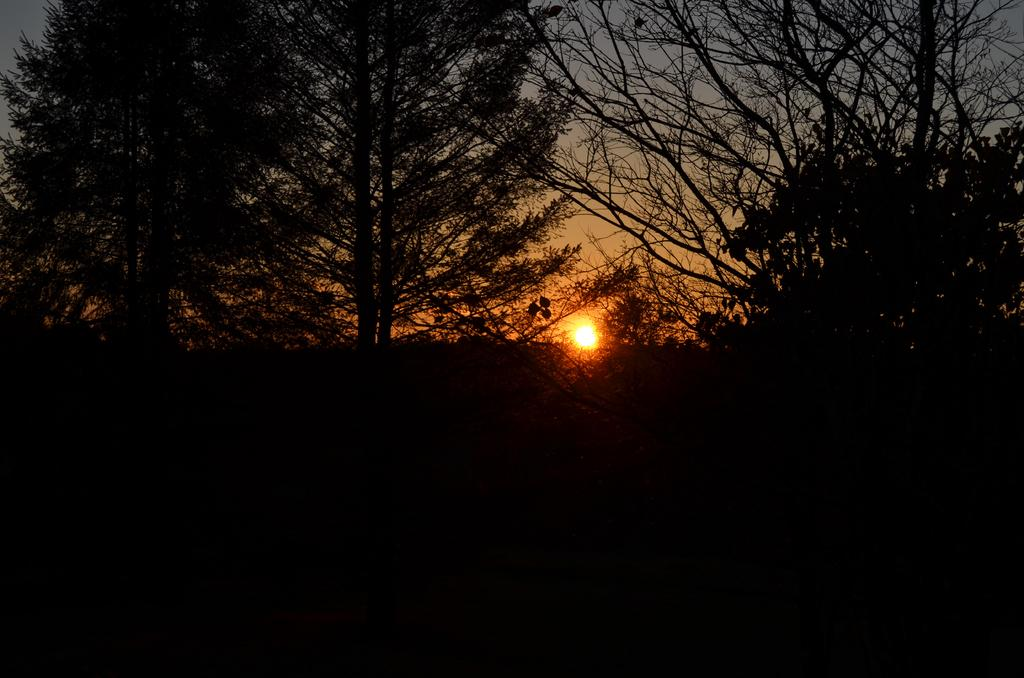What type of vegetation is visible in the front of the image? There are trees in the front of the image. What part of the natural environment is visible in the background of the image? The sky is visible in the background of the image. Can the Sun be seen in the sky? Yes, the Sun is observable in the sky. Where is the toothbrush placed in the image? There is no toothbrush present in the image. 